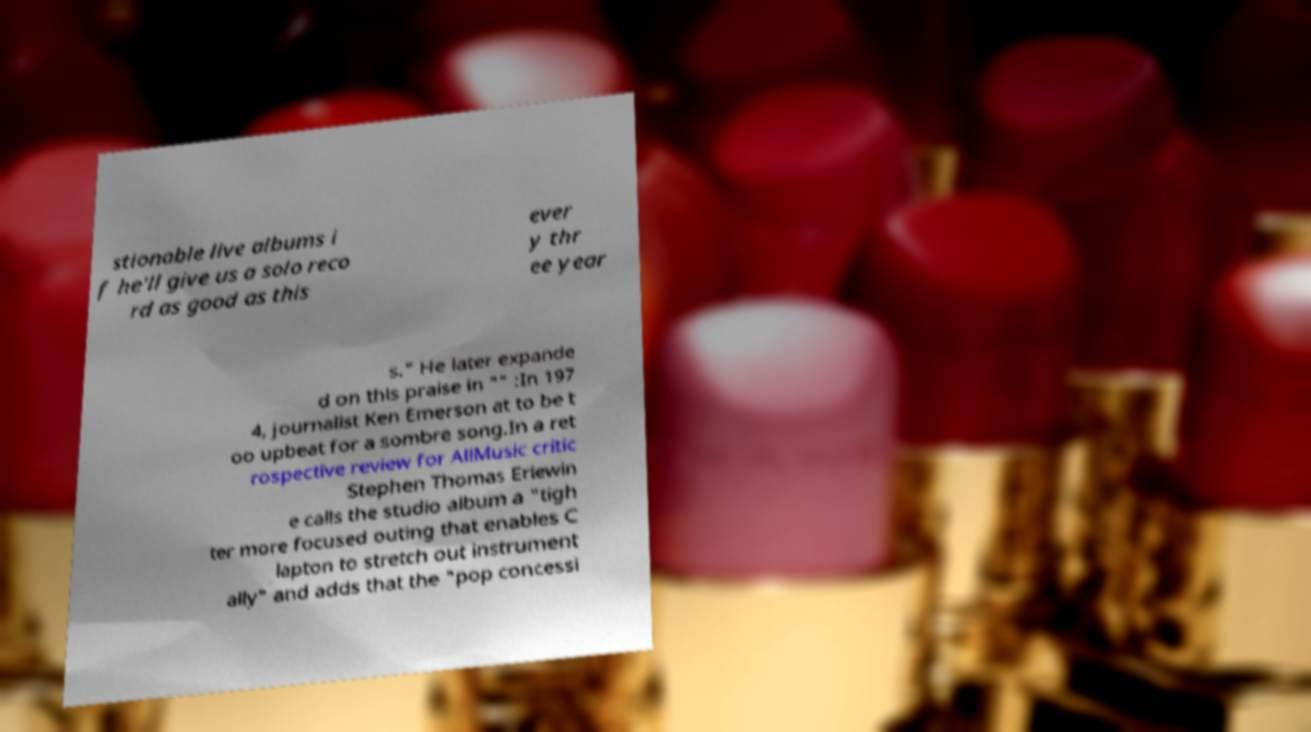Could you extract and type out the text from this image? stionable live albums i f he'll give us a solo reco rd as good as this ever y thr ee year s." He later expande d on this praise in "" :In 197 4, journalist Ken Emerson at to be t oo upbeat for a sombre song.In a ret rospective review for AllMusic critic Stephen Thomas Erlewin e calls the studio album a "tigh ter more focused outing that enables C lapton to stretch out instrument ally" and adds that the "pop concessi 